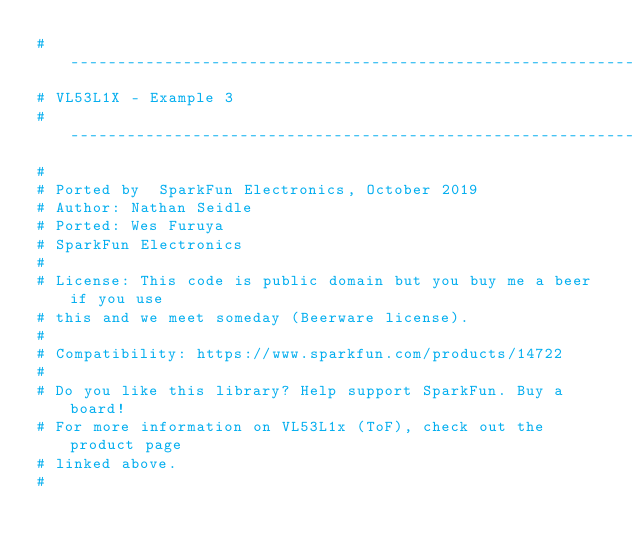Convert code to text. <code><loc_0><loc_0><loc_500><loc_500><_Python_>#-----------------------------------------------------------------------
# VL53L1X - Example 3
#-----------------------------------------------------------------------
#
# Ported by  SparkFun Electronics, October 2019
# Author: Nathan Seidle
# Ported: Wes Furuya
# SparkFun Electronics
# 
# License: This code is public domain but you buy me a beer if you use
# this and we meet someday (Beerware license).
#
# Compatibility: https://www.sparkfun.com/products/14722
# 
# Do you like this library? Help support SparkFun. Buy a board!
# For more information on VL53L1x (ToF), check out the product page
# linked above.
#</code> 